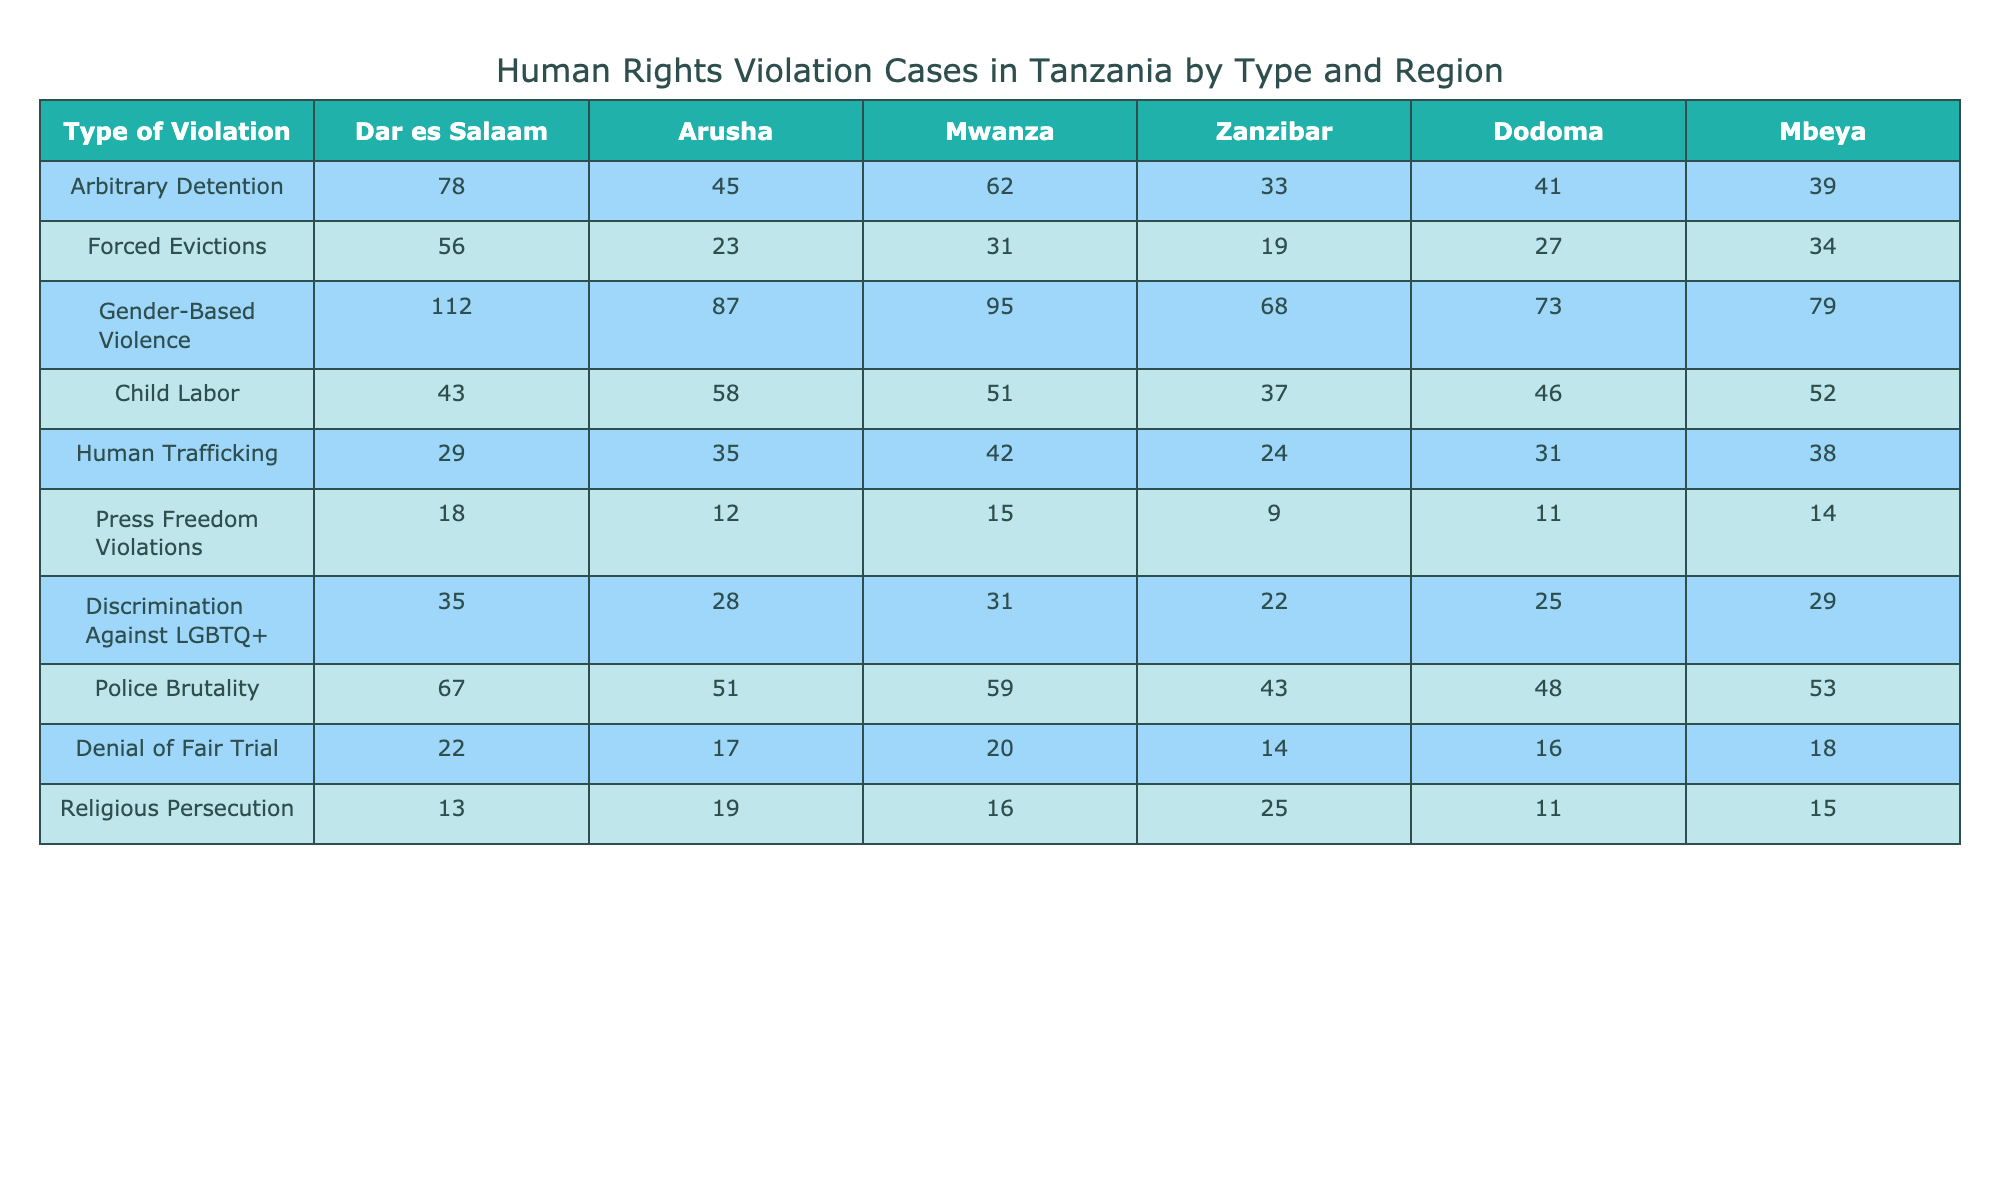What is the highest number of cases for Gender-Based Violence, and in which region does it occur? The highest number of cases is 112 for Gender-Based Violence, which occurs in Dar es Salaam.
Answer: 112 in Dar es Salaam How many cases of Child Labor were reported in Zanzibar? According to the table, the reported cases of Child Labor in Zanzibar are 37.
Answer: 37 Which type of violation has the least cases reported in Mbeya? In Mbeya, the type of violation with the least reported cases is Religious Persecution with 15 cases.
Answer: Religious Persecution with 15 cases What is the total number of Forced Evictions reported across all regions? The totals for Forced Evictions in all regions are 56 + 23 + 31 + 19 + 27 + 34 = 190, so the total is 190.
Answer: 190 Is there a higher number of cases for Arbitrary Detention in Mwanza than in Dodoma? In Mwanza, there are 62 cases, while in Dodoma, there are 41 cases. Since 62 is greater than 41, the statement is true.
Answer: Yes What is the average number of cases for Police Brutality across all regions? The sum for Police Brutality across regions is 67 + 51 + 59 + 43 + 48 + 53 = 321. There are 6 regions, so the average is 321 / 6 = 53.5.
Answer: 53.5 Which type of violation had more cases in Arusha than in Zanzibar, and how many more? In Arusha, Gender-Based Violence had 87 cases while in Zanzibar it had 68, resulting in 87 - 68 = 19 more cases in Arusha.
Answer: Gender-Based Violence with 19 more cases What is the total number of cases for Human Trafficking across all regions? The total for Human Trafficking is calculated as 29 + 35 + 42 + 24 + 31 + 38 = 199.
Answer: 199 In which region is the number of Discrimination Against LGBTQ+ cases closest to the number of Press Freedom Violations? In Dodoma, Discrimination Against LGBTQ+ cases is 25 and Press Freedom Violations is 11, yielding a difference of 14. In Mbeya, Discrimination Against LGBTQ+ is 29 and Press Freedom Violations is 14, giving a difference of 15. Thus, Dodoma has cases closer with a difference of 14.
Answer: Dodoma 